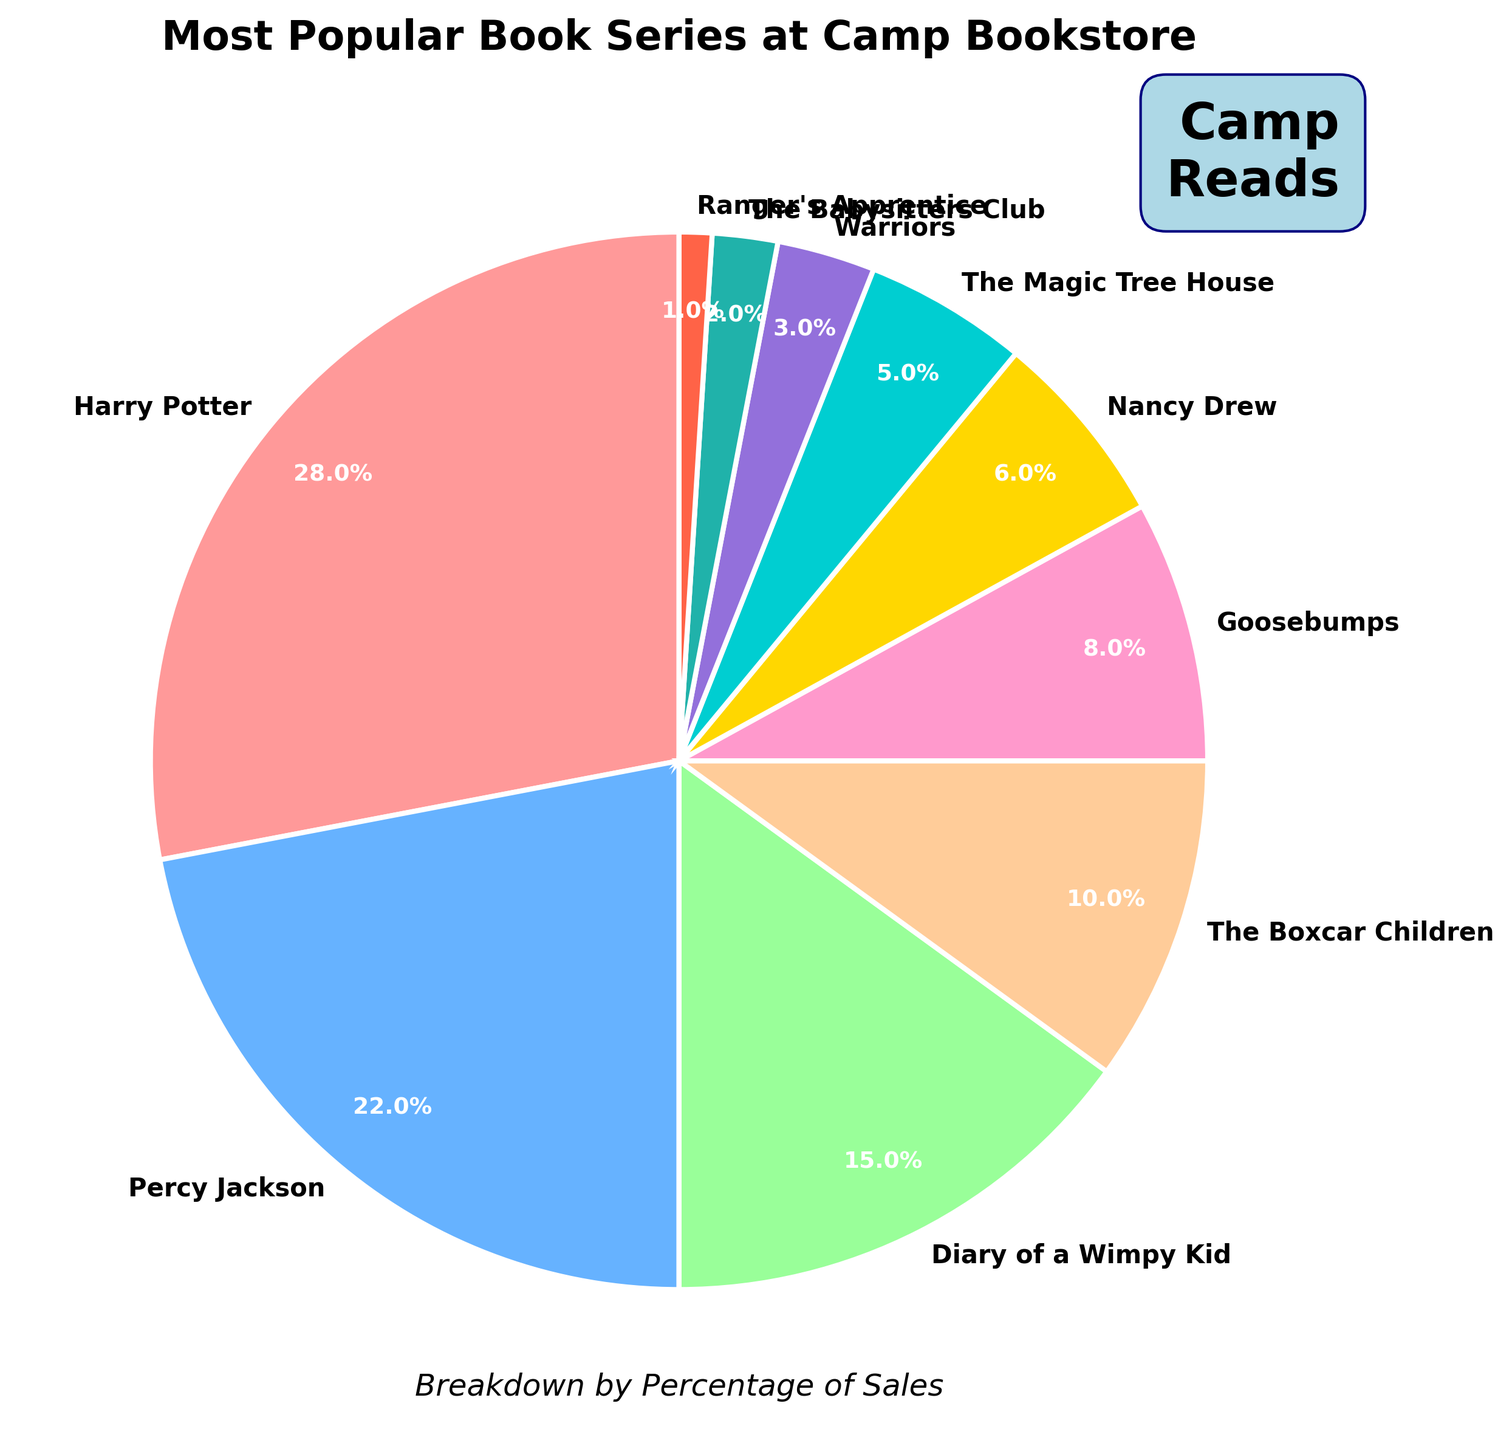Which book series is the most popular at the camp bookstore? The pie chart shows that "Harry Potter" has the largest slice, which represents 28% of the total sales.
Answer: Harry Potter Which two book series together account for the highest percentage of sales? The two largest slices represent "Harry Potter" with 28% and "Percy Jackson" with 22%. Together, they account for 28% + 22% = 50%.
Answer: Harry Potter and Percy Jackson What is the combined percentage of sales for "Nancy Drew" and "The Magic Tree House"? "Nancy Drew" contributes 6% and "The Magic Tree House" contributes 5%, making their combined percentage 6% + 5% = 11%.
Answer: 11% Which series has a lower percentage of sales than "Goosebumps" but higher than "Warriors"? By examining the slices, "Nancy Drew" has a lower percentage than "Goosebumps" (8%) and a higher percentage than "Warriors" (3%), at 6%.
Answer: Nancy Drew How does the percentage of sales for "Diary of a Wimpy Kid" compare to the sales for "The Boxcar Children"? "Diary of a Wimpy Kid" has a percentage of 15%, which is greater than the 10% for "The Boxcar Children". This is clear from the larger slice for "Diary of a Wimpy Kid".
Answer: Greater Which series has a smaller percentage of sales: "The Babysitters Club" or "Ranger's Apprentice"? "The Babysitters Club" has 2% of the sales, which is larger than "Ranger's Apprentice" with 1%.
Answer: Ranger's Apprentice What fraction of the total sales is represented by "Goosebumps" and "Nancy Drew" together? "Goosebumps" has 8% and "Nancy Drew" has 6%, so together they represent 8% + 6% = 14%.
Answer: 14% What is the relative size of the slice for "Percy Jackson" compared to the slice for "Harry Potter"? "Percy Jackson" has 22% of the total sales, while "Harry Potter" has 28%. To compare, 22% is approximately 78.57% of 28%.
Answer: Smaller What series ranks third in terms of popularity based on the sales percentage? The third largest slice belongs to "Diary of a Wimpy Kid" with 15% of the sales, following "Harry Potter" and "Percy Jackson".
Answer: Diary of a Wimpy Kid If you combined "Warriors", "The Babysitters Club", and "Ranger's Apprentice", what would their total percentage be? Adding the percentages for "Warriors" (3%), "The Babysitters Club" (2%), and "Ranger's Apprentice" (1%) gives a total of 3% + 2% + 1% = 6%.
Answer: 6% 